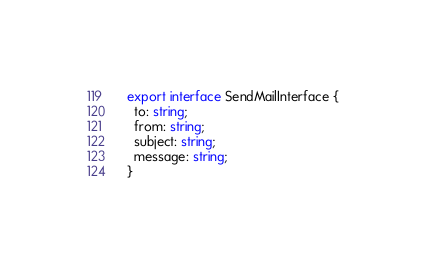Convert code to text. <code><loc_0><loc_0><loc_500><loc_500><_TypeScript_>export interface SendMailInterface {
  to: string;
  from: string;
  subject: string;
  message: string;
}
</code> 